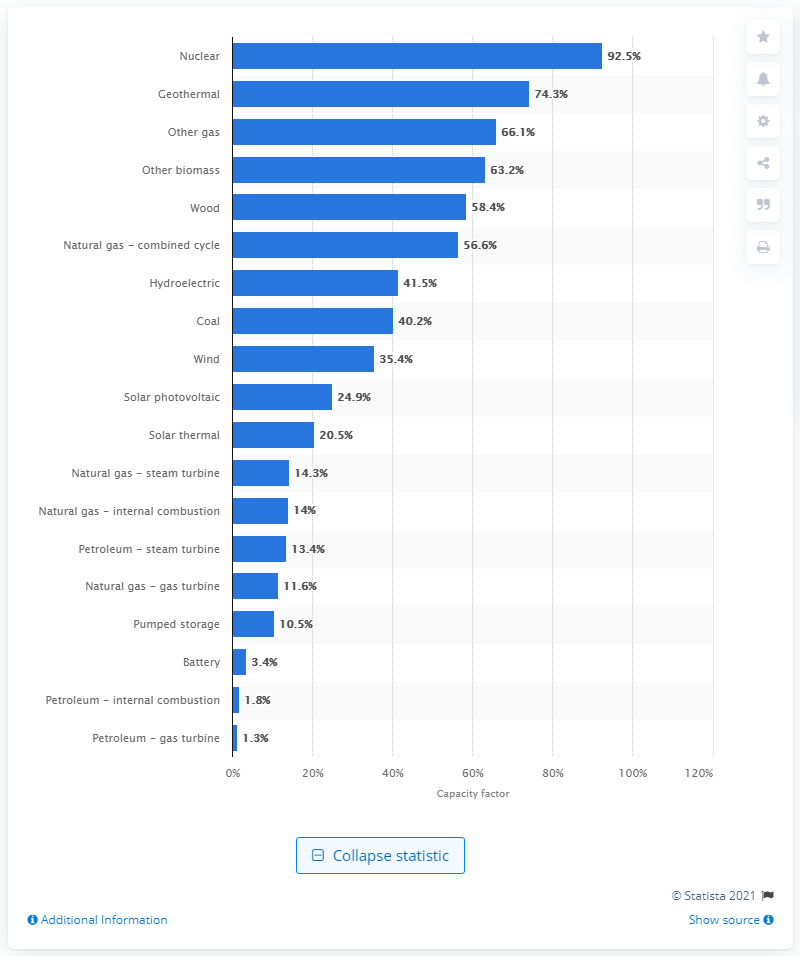Identify some key points in this picture. The ratio of natural gas-fired combined cycle power generation to maximum output was 56.6%. 